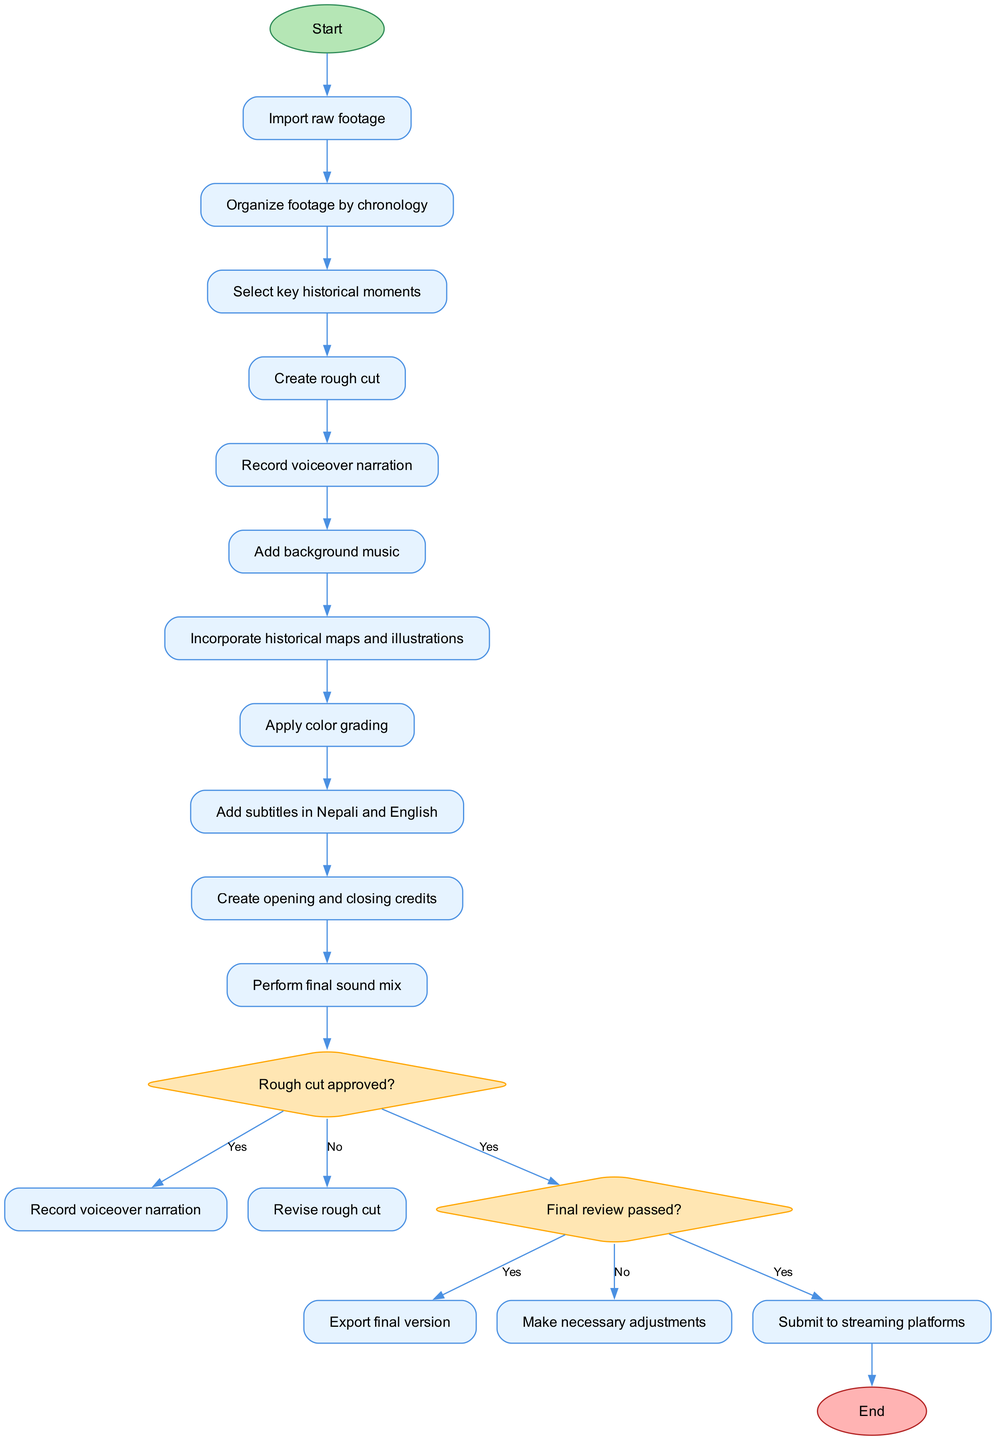What is the first activity in the workflow? The first activity is indicated directly after the start node in the diagram, which states "Import raw footage".
Answer: Import raw footage How many activities are there in total? The diagram lists ten activities, starting from "Organize footage by chronology" to "Perform final sound mix".
Answer: 10 What happens after the rough cut is approved? If the rough cut is approved, the next step indicated in the diagram is to "Record voiceover narration".
Answer: Record voiceover narration What is the last activity before submitting to streaming platforms? The last activity before submission is indicated as "Perform final sound mix", which leads to the final review decision.
Answer: Perform final sound mix What decision occurs after the final sound mix? After the final sound mix, the decision to be made is whether the "Final review passed?".
Answer: Final review passed? If the final review does not pass, what action is taken? If the final review does not pass, the diagram indicates that "Make necessary adjustments" is the subsequent action taken.
Answer: Make necessary adjustments How is the end of the workflow represented in the diagram? The diagram indicates the end of the workflow with an "End" node that signifies the completion of the process following submission.
Answer: End Which activity immediately follows the activity of adding subtitles? The immediate next activity after "Add subtitles in Nepali and English" is "Create opening and closing credits".
Answer: Create opening and closing credits Before which activity is the decision about the rough cut made? The decision about the rough cut occurs after the activity "Create rough cut" and before proceeding to "Record voiceover narration".
Answer: Create rough cut 